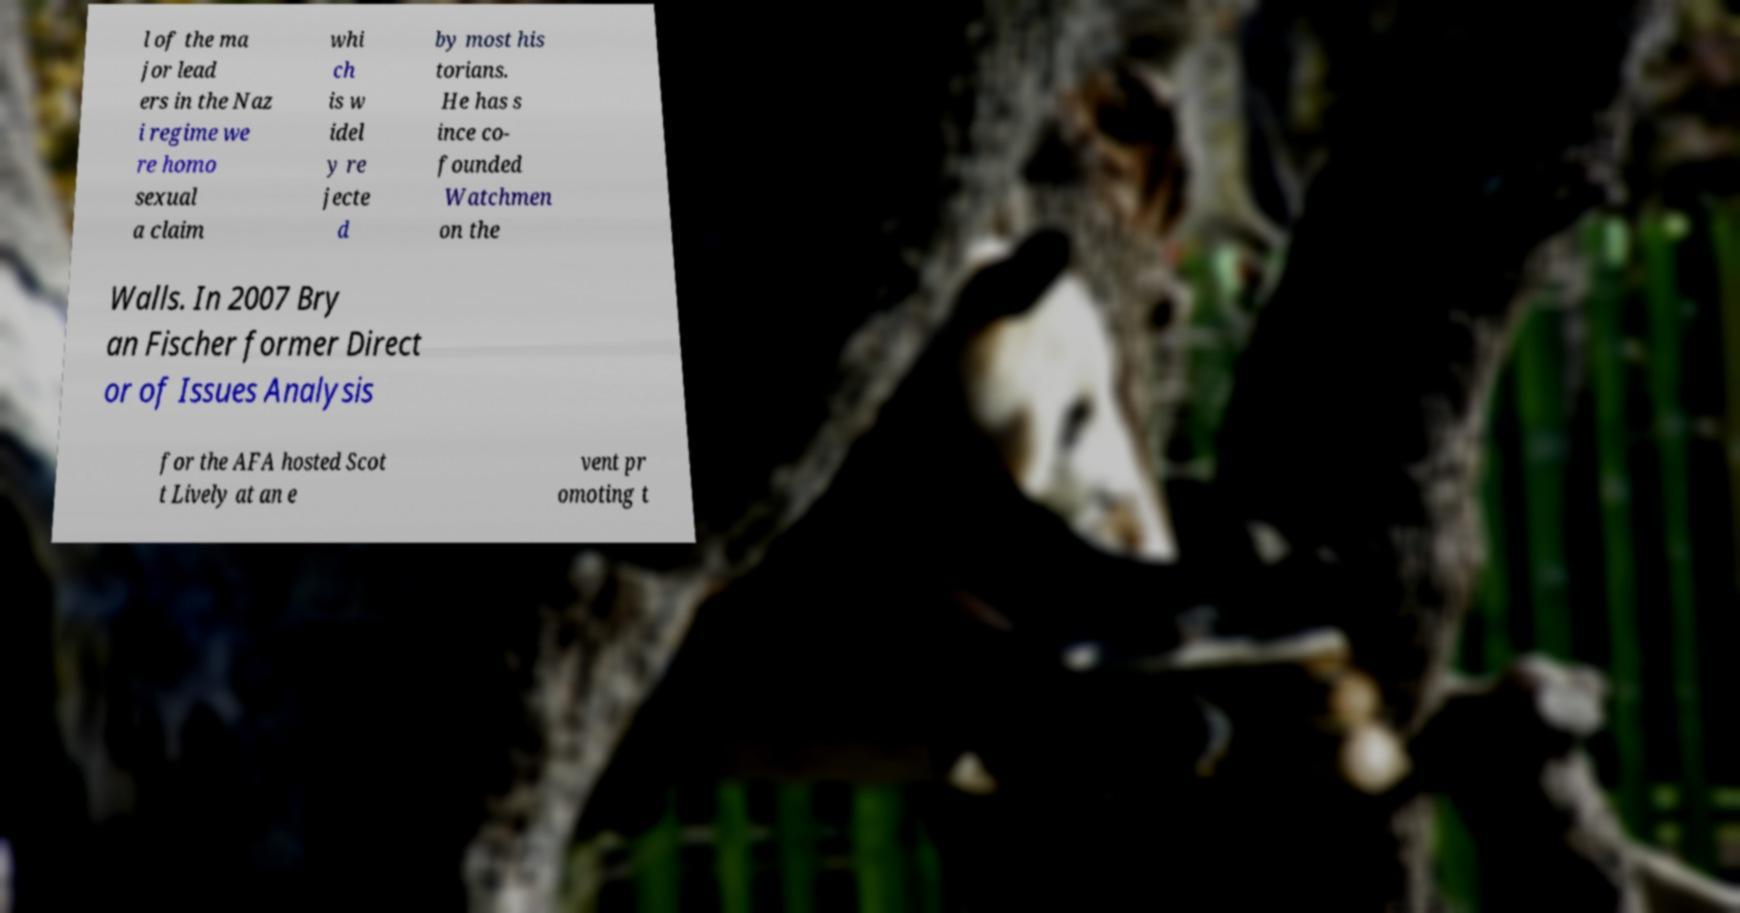Could you assist in decoding the text presented in this image and type it out clearly? l of the ma jor lead ers in the Naz i regime we re homo sexual a claim whi ch is w idel y re jecte d by most his torians. He has s ince co- founded Watchmen on the Walls. In 2007 Bry an Fischer former Direct or of Issues Analysis for the AFA hosted Scot t Lively at an e vent pr omoting t 